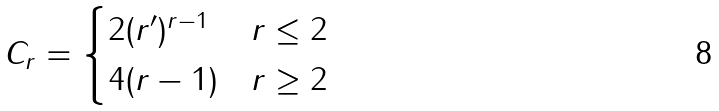<formula> <loc_0><loc_0><loc_500><loc_500>C _ { r } = \begin{cases} 2 ( r ^ { \prime } ) ^ { r - 1 } & r \leq 2 \\ 4 ( r - 1 ) & r \geq 2 \end{cases}</formula> 